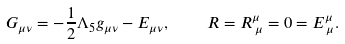Convert formula to latex. <formula><loc_0><loc_0><loc_500><loc_500>G _ { \mu \nu } = - \frac { 1 } { 2 } \Lambda _ { 5 } g _ { \mu \nu } - E _ { \mu \nu } , \quad R = R ^ { \mu } _ { \, \mu } = 0 = E ^ { \mu } _ { \, \mu } .</formula> 